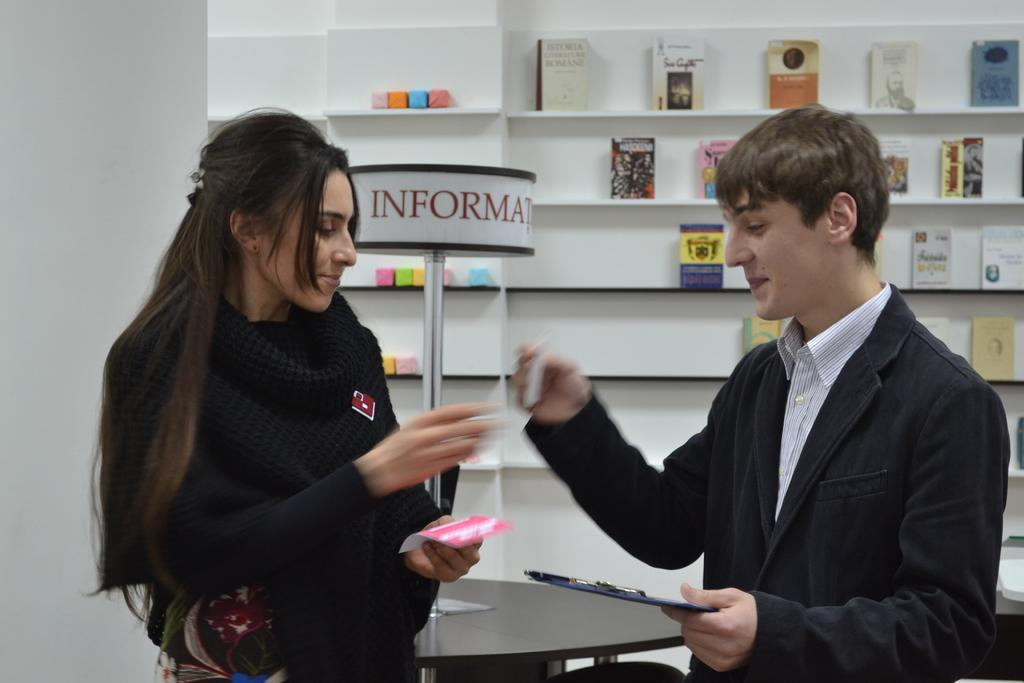Who are the people in the image? There is a woman and a man in the image. What are the expressions on their faces? Both the woman and the man are smiling. What is the man wearing? The man is wearing a coat. What can be seen in the background of the image? There are books placed in a shelf in the background of the image. What type of butter is being used to clean the dirt off the condition of the books in the image? There is no butter or dirt present in the image, and the condition of the books is not mentioned. 